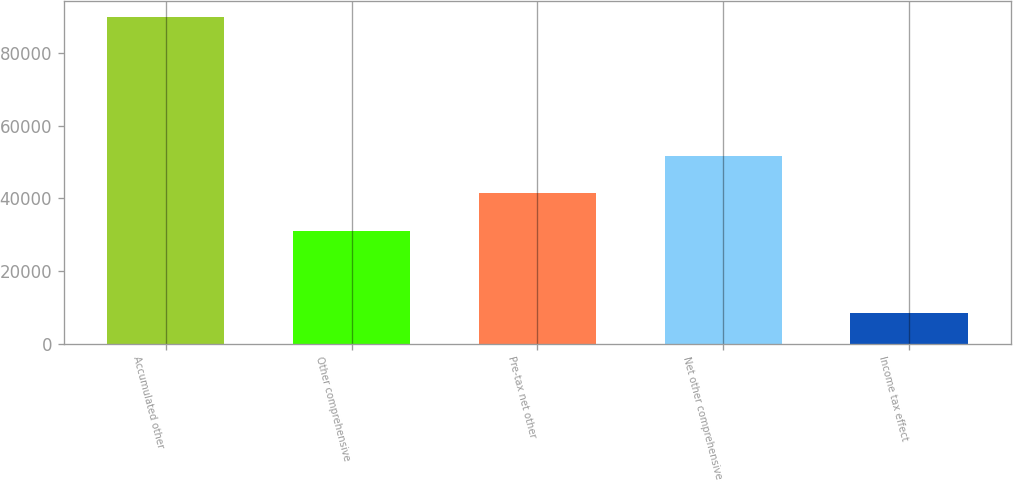Convert chart to OTSL. <chart><loc_0><loc_0><loc_500><loc_500><bar_chart><fcel>Accumulated other<fcel>Other comprehensive<fcel>Pre-tax net other<fcel>Net other comprehensive<fcel>Income tax effect<nl><fcel>89924.4<fcel>31086<fcel>41333.4<fcel>51580.8<fcel>8289<nl></chart> 